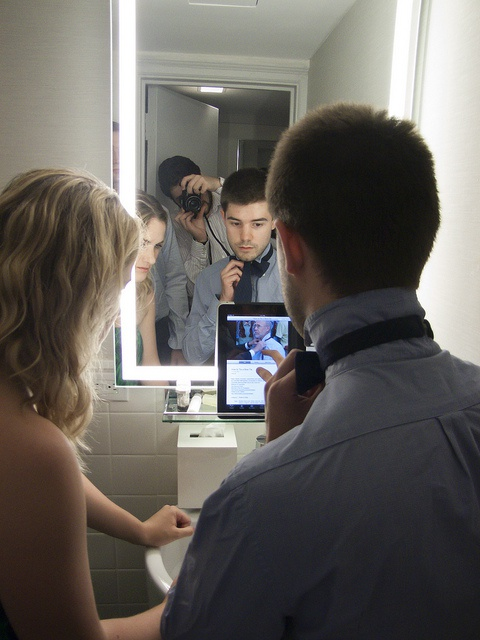Describe the objects in this image and their specific colors. I can see people in gray and black tones, people in gray, black, and maroon tones, people in gray, black, darkgray, and tan tones, tv in gray, black, lavender, navy, and darkgray tones, and people in gray and black tones in this image. 